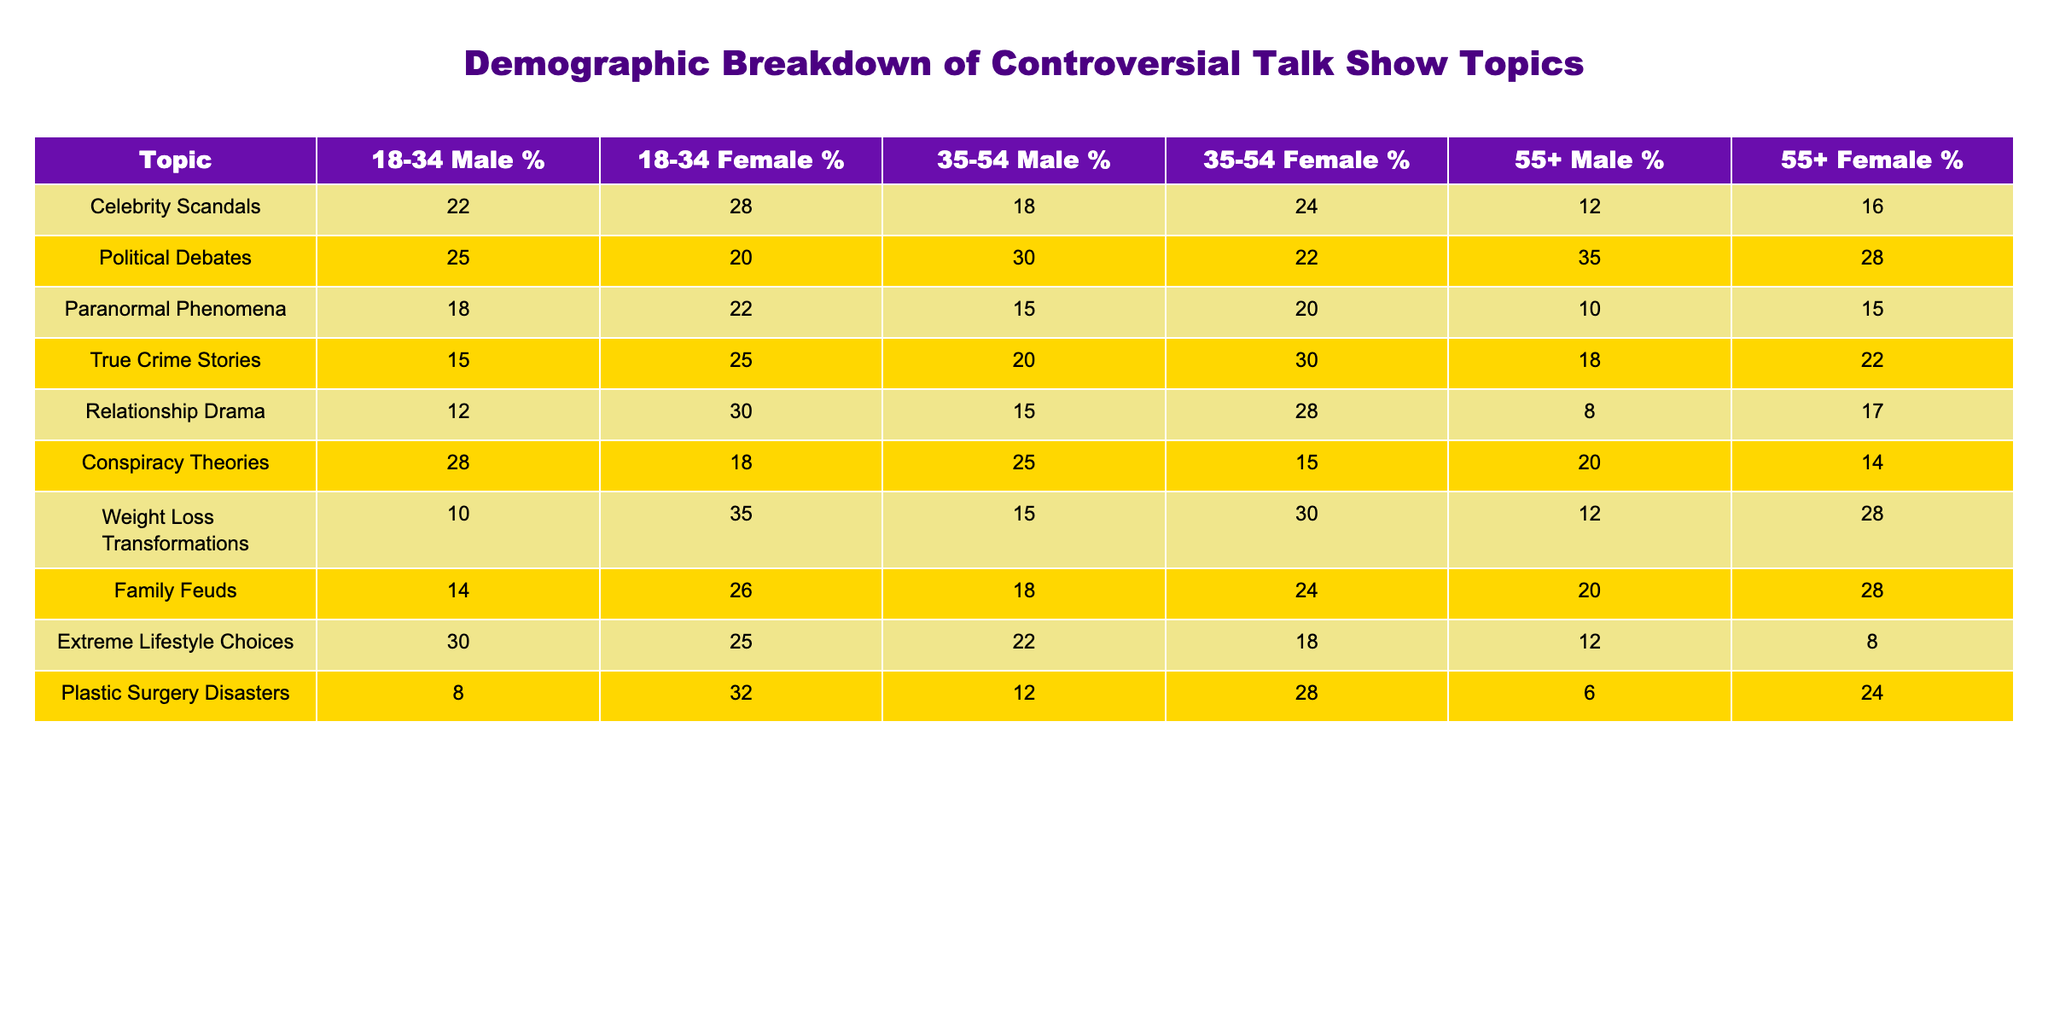What percentage of 18-34 males are interested in Celebrity Scandals? The table shows the percentage of 18-34 males, which is specifically listed under the "18-34 Male %" column for the topic "Celebrity Scandals." The value is 22%.
Answer: 22% Which topic has the highest percentage of interest from 55+ females? To determine which topic has the highest interest from 55+ females, we check the "55+ Female %" column. The highest value is 28%, found in both "Weight Loss Transformations" and "Family Feuds." However, since we are only interested in the highest, one can mention both.
Answer: 28% What is the average percentage of interest among 35-54 males across all topics? We sum all the percentages of 35-54 males (30 + 25 + 20 + 15 + 18 + 25 + 15 + 18 + 22) = 178. There are 9 topics, so the average percentage is 178/9 ≈ 19.78%.
Answer: Approximately 19.78% Is the interest in Political Debates among 18-34 males higher than that for True Crime Stories? The percentage for Political Debates among 18-34 males is 25%, while the percentage for True Crime Stories in the same demographic is 15%. Since 25% is greater than 15%, the statement is true.
Answer: Yes What is the difference in percentage points between the interest of 18-34 females in Plastic Surgery Disasters and Relationship Drama? The percentage of interest for 18-34 females in Plastic Surgery Disasters is 32%, and for Relationship Drama, it is 30%. The difference is 32% - 30% = 2%.
Answer: 2% Which age and gender demographic has the lowest percentage of interest in Extreme Lifestyle Choices? Looking at the "Extreme Lifestyle Choices" row, we see that the lowest percentage is for 55+ females, which is 8%.
Answer: 8% What topic appeals more to 35-54 females than to 55+ males, according to the data? We check the rows for each topic under both the "35-54 Female %" and "55+ Male %" columns. After comparing, we can see that "Relationship Drama" (28% vs 8%) and "Family Feuds" (24% vs 20%) both appeal more to 35-54 females than to 55+ males.
Answer: Relationship Drama and Family Feuds What percentage of 18-34 males prefer Conspiracy Theories over Celebrity Scandals? The percentage of 18-34 males interested in Conspiracy Theories is 28%, while for Celebrity Scandals, it is 22%. The difference is calculated as 28% - 22% = 6%.
Answer: 6% What is the total percentage of interest in True Crime Stories for all demographics combined? To find this, we sum the percentages from all demographics for True Crime Stories: (15 + 25 + 20 + 30 + 18 + 22) = 130%. Total interest across all demographics equals 130%.
Answer: 130% Is it true that more 35-54 males are interested in Political Debates than in Celebrity Scandals? Checking the percentages, 35-54 males have 30% for Political Debates and 18% for Celebrity Scandals. Since 30% is greater than 18%, it is true.
Answer: Yes 